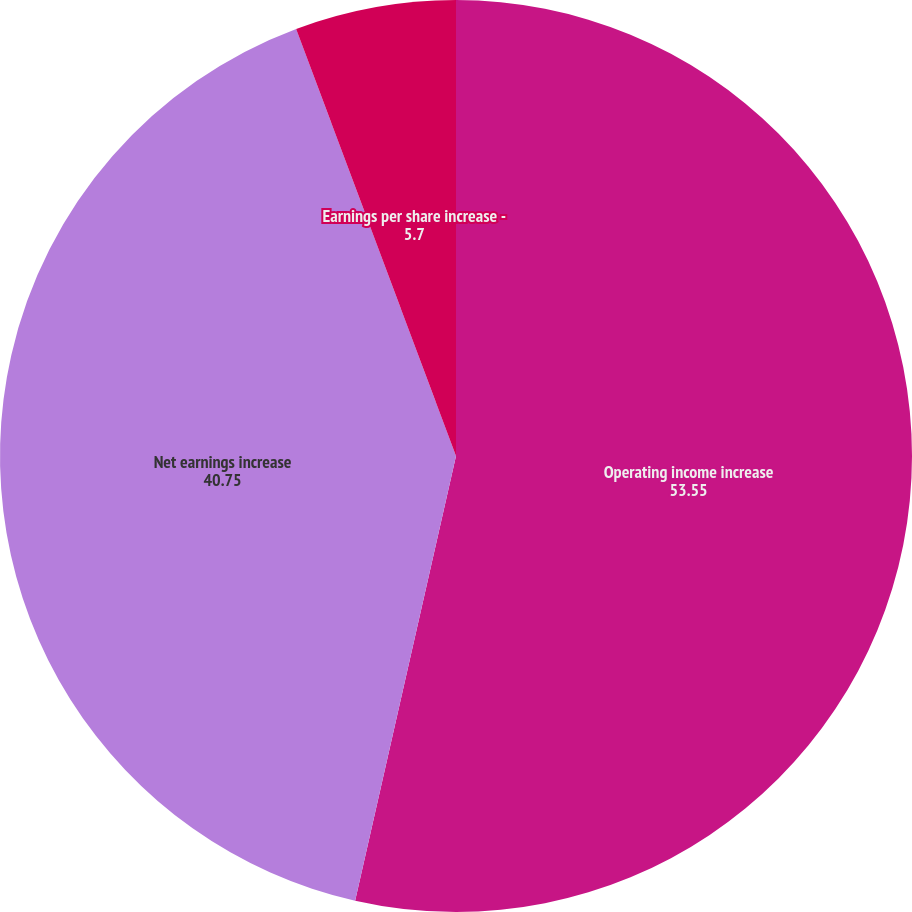Convert chart. <chart><loc_0><loc_0><loc_500><loc_500><pie_chart><fcel>Operating income increase<fcel>Net earnings increase<fcel>Earnings per share increase -<nl><fcel>53.55%<fcel>40.75%<fcel>5.7%<nl></chart> 